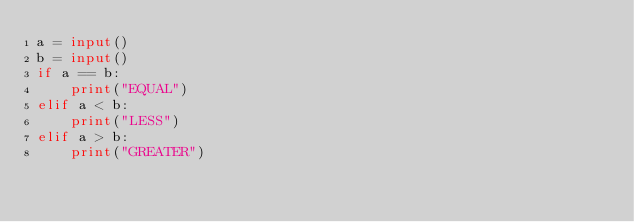Convert code to text. <code><loc_0><loc_0><loc_500><loc_500><_Python_>a = input()
b = input()
if a == b:
    print("EQUAL")
elif a < b:
    print("LESS")
elif a > b:
    print("GREATER")</code> 